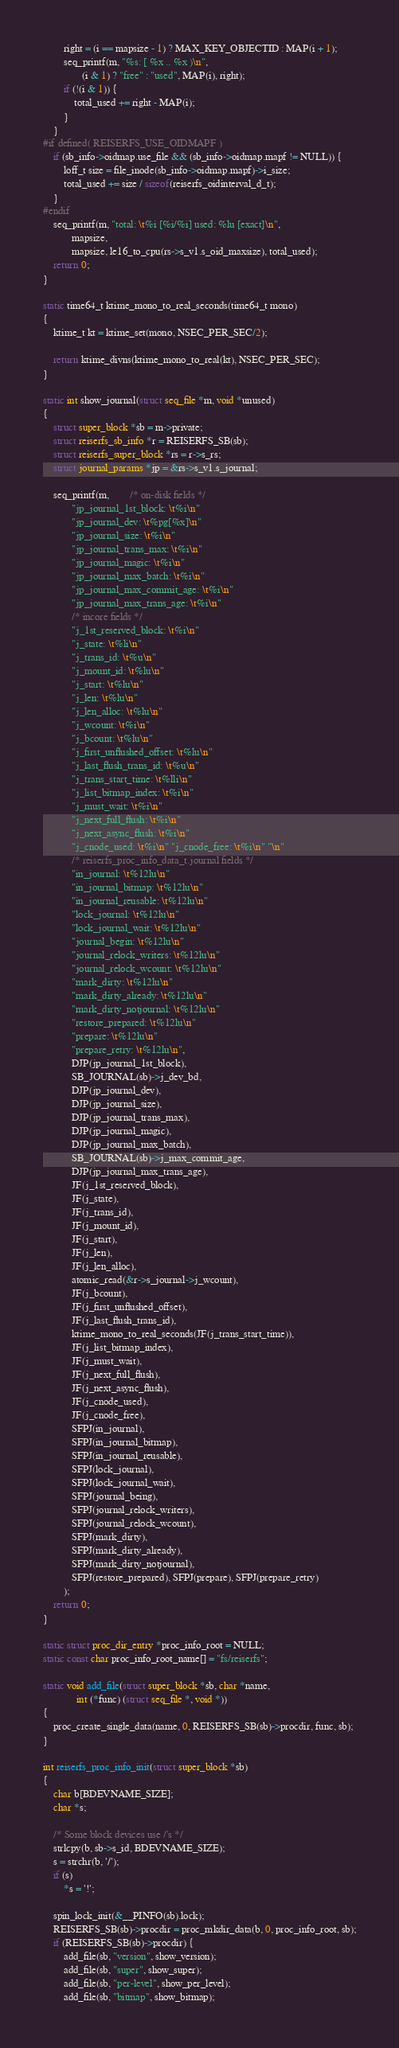Convert code to text. <code><loc_0><loc_0><loc_500><loc_500><_C_>		right = (i == mapsize - 1) ? MAX_KEY_OBJECTID : MAP(i + 1);
		seq_printf(m, "%s: [ %x .. %x )\n",
			   (i & 1) ? "free" : "used", MAP(i), right);
		if (!(i & 1)) {
			total_used += right - MAP(i);
		}
	}
#if defined( REISERFS_USE_OIDMAPF )
	if (sb_info->oidmap.use_file && (sb_info->oidmap.mapf != NULL)) {
		loff_t size = file_inode(sb_info->oidmap.mapf)->i_size;
		total_used += size / sizeof(reiserfs_oidinterval_d_t);
	}
#endif
	seq_printf(m, "total: \t%i [%i/%i] used: %lu [exact]\n",
		   mapsize,
		   mapsize, le16_to_cpu(rs->s_v1.s_oid_maxsize), total_used);
	return 0;
}

static time64_t ktime_mono_to_real_seconds(time64_t mono)
{
	ktime_t kt = ktime_set(mono, NSEC_PER_SEC/2);

	return ktime_divns(ktime_mono_to_real(kt), NSEC_PER_SEC);
}

static int show_journal(struct seq_file *m, void *unused)
{
	struct super_block *sb = m->private;
	struct reiserfs_sb_info *r = REISERFS_SB(sb);
	struct reiserfs_super_block *rs = r->s_rs;
	struct journal_params *jp = &rs->s_v1.s_journal;

	seq_printf(m,		/* on-disk fields */
		   "jp_journal_1st_block: \t%i\n"
		   "jp_journal_dev: \t%pg[%x]\n"
		   "jp_journal_size: \t%i\n"
		   "jp_journal_trans_max: \t%i\n"
		   "jp_journal_magic: \t%i\n"
		   "jp_journal_max_batch: \t%i\n"
		   "jp_journal_max_commit_age: \t%i\n"
		   "jp_journal_max_trans_age: \t%i\n"
		   /* incore fields */
		   "j_1st_reserved_block: \t%i\n"
		   "j_state: \t%li\n"
		   "j_trans_id: \t%u\n"
		   "j_mount_id: \t%lu\n"
		   "j_start: \t%lu\n"
		   "j_len: \t%lu\n"
		   "j_len_alloc: \t%lu\n"
		   "j_wcount: \t%i\n"
		   "j_bcount: \t%lu\n"
		   "j_first_unflushed_offset: \t%lu\n"
		   "j_last_flush_trans_id: \t%u\n"
		   "j_trans_start_time: \t%lli\n"
		   "j_list_bitmap_index: \t%i\n"
		   "j_must_wait: \t%i\n"
		   "j_next_full_flush: \t%i\n"
		   "j_next_async_flush: \t%i\n"
		   "j_cnode_used: \t%i\n" "j_cnode_free: \t%i\n" "\n"
		   /* reiserfs_proc_info_data_t.journal fields */
		   "in_journal: \t%12lu\n"
		   "in_journal_bitmap: \t%12lu\n"
		   "in_journal_reusable: \t%12lu\n"
		   "lock_journal: \t%12lu\n"
		   "lock_journal_wait: \t%12lu\n"
		   "journal_begin: \t%12lu\n"
		   "journal_relock_writers: \t%12lu\n"
		   "journal_relock_wcount: \t%12lu\n"
		   "mark_dirty: \t%12lu\n"
		   "mark_dirty_already: \t%12lu\n"
		   "mark_dirty_notjournal: \t%12lu\n"
		   "restore_prepared: \t%12lu\n"
		   "prepare: \t%12lu\n"
		   "prepare_retry: \t%12lu\n",
		   DJP(jp_journal_1st_block),
		   SB_JOURNAL(sb)->j_dev_bd,
		   DJP(jp_journal_dev),
		   DJP(jp_journal_size),
		   DJP(jp_journal_trans_max),
		   DJP(jp_journal_magic),
		   DJP(jp_journal_max_batch),
		   SB_JOURNAL(sb)->j_max_commit_age,
		   DJP(jp_journal_max_trans_age),
		   JF(j_1st_reserved_block),
		   JF(j_state),
		   JF(j_trans_id),
		   JF(j_mount_id),
		   JF(j_start),
		   JF(j_len),
		   JF(j_len_alloc),
		   atomic_read(&r->s_journal->j_wcount),
		   JF(j_bcount),
		   JF(j_first_unflushed_offset),
		   JF(j_last_flush_trans_id),
		   ktime_mono_to_real_seconds(JF(j_trans_start_time)),
		   JF(j_list_bitmap_index),
		   JF(j_must_wait),
		   JF(j_next_full_flush),
		   JF(j_next_async_flush),
		   JF(j_cnode_used),
		   JF(j_cnode_free),
		   SFPJ(in_journal),
		   SFPJ(in_journal_bitmap),
		   SFPJ(in_journal_reusable),
		   SFPJ(lock_journal),
		   SFPJ(lock_journal_wait),
		   SFPJ(journal_being),
		   SFPJ(journal_relock_writers),
		   SFPJ(journal_relock_wcount),
		   SFPJ(mark_dirty),
		   SFPJ(mark_dirty_already),
		   SFPJ(mark_dirty_notjournal),
		   SFPJ(restore_prepared), SFPJ(prepare), SFPJ(prepare_retry)
	    );
	return 0;
}

static struct proc_dir_entry *proc_info_root = NULL;
static const char proc_info_root_name[] = "fs/reiserfs";

static void add_file(struct super_block *sb, char *name,
		     int (*func) (struct seq_file *, void *))
{
	proc_create_single_data(name, 0, REISERFS_SB(sb)->procdir, func, sb);
}

int reiserfs_proc_info_init(struct super_block *sb)
{
	char b[BDEVNAME_SIZE];
	char *s;

	/* Some block devices use /'s */
	strlcpy(b, sb->s_id, BDEVNAME_SIZE);
	s = strchr(b, '/');
	if (s)
		*s = '!';

	spin_lock_init(&__PINFO(sb).lock);
	REISERFS_SB(sb)->procdir = proc_mkdir_data(b, 0, proc_info_root, sb);
	if (REISERFS_SB(sb)->procdir) {
		add_file(sb, "version", show_version);
		add_file(sb, "super", show_super);
		add_file(sb, "per-level", show_per_level);
		add_file(sb, "bitmap", show_bitmap);</code> 